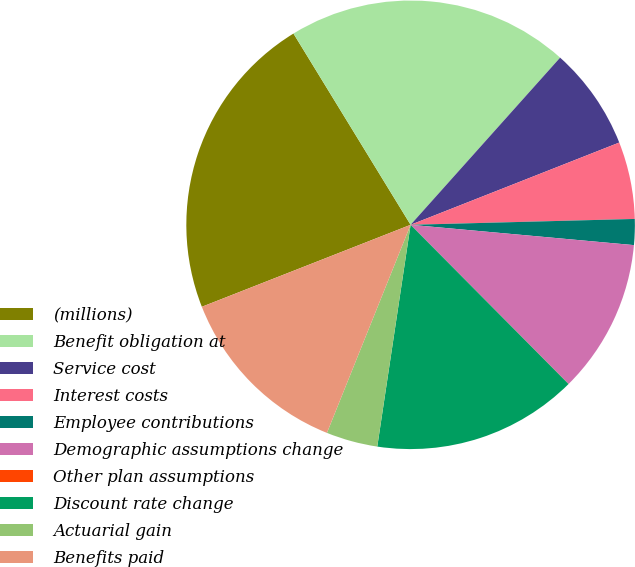Convert chart to OTSL. <chart><loc_0><loc_0><loc_500><loc_500><pie_chart><fcel>(millions)<fcel>Benefit obligation at<fcel>Service cost<fcel>Interest costs<fcel>Employee contributions<fcel>Demographic assumptions change<fcel>Other plan assumptions<fcel>Discount rate change<fcel>Actuarial gain<fcel>Benefits paid<nl><fcel>22.21%<fcel>20.36%<fcel>7.41%<fcel>5.56%<fcel>1.86%<fcel>11.11%<fcel>0.01%<fcel>14.81%<fcel>3.71%<fcel>12.96%<nl></chart> 